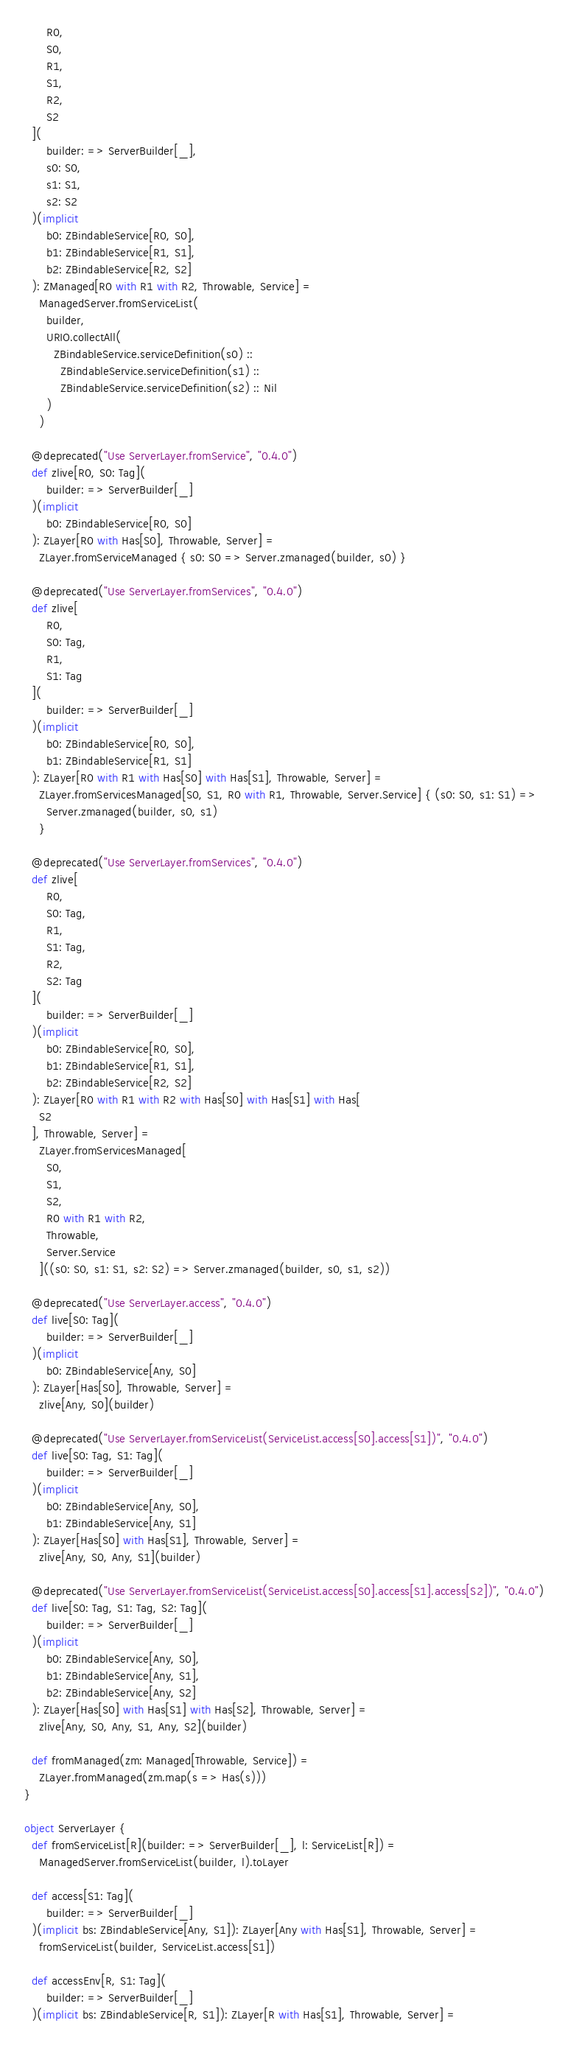Convert code to text. <code><loc_0><loc_0><loc_500><loc_500><_Scala_>      R0,
      S0,
      R1,
      S1,
      R2,
      S2
  ](
      builder: => ServerBuilder[_],
      s0: S0,
      s1: S1,
      s2: S2
  )(implicit
      b0: ZBindableService[R0, S0],
      b1: ZBindableService[R1, S1],
      b2: ZBindableService[R2, S2]
  ): ZManaged[R0 with R1 with R2, Throwable, Service] =
    ManagedServer.fromServiceList(
      builder,
      URIO.collectAll(
        ZBindableService.serviceDefinition(s0) ::
          ZBindableService.serviceDefinition(s1) ::
          ZBindableService.serviceDefinition(s2) :: Nil
      )
    )

  @deprecated("Use ServerLayer.fromService", "0.4.0")
  def zlive[R0, S0: Tag](
      builder: => ServerBuilder[_]
  )(implicit
      b0: ZBindableService[R0, S0]
  ): ZLayer[R0 with Has[S0], Throwable, Server] =
    ZLayer.fromServiceManaged { s0: S0 => Server.zmanaged(builder, s0) }

  @deprecated("Use ServerLayer.fromServices", "0.4.0")
  def zlive[
      R0,
      S0: Tag,
      R1,
      S1: Tag
  ](
      builder: => ServerBuilder[_]
  )(implicit
      b0: ZBindableService[R0, S0],
      b1: ZBindableService[R1, S1]
  ): ZLayer[R0 with R1 with Has[S0] with Has[S1], Throwable, Server] =
    ZLayer.fromServicesManaged[S0, S1, R0 with R1, Throwable, Server.Service] { (s0: S0, s1: S1) =>
      Server.zmanaged(builder, s0, s1)
    }

  @deprecated("Use ServerLayer.fromServices", "0.4.0")
  def zlive[
      R0,
      S0: Tag,
      R1,
      S1: Tag,
      R2,
      S2: Tag
  ](
      builder: => ServerBuilder[_]
  )(implicit
      b0: ZBindableService[R0, S0],
      b1: ZBindableService[R1, S1],
      b2: ZBindableService[R2, S2]
  ): ZLayer[R0 with R1 with R2 with Has[S0] with Has[S1] with Has[
    S2
  ], Throwable, Server] =
    ZLayer.fromServicesManaged[
      S0,
      S1,
      S2,
      R0 with R1 with R2,
      Throwable,
      Server.Service
    ]((s0: S0, s1: S1, s2: S2) => Server.zmanaged(builder, s0, s1, s2))

  @deprecated("Use ServerLayer.access", "0.4.0")
  def live[S0: Tag](
      builder: => ServerBuilder[_]
  )(implicit
      b0: ZBindableService[Any, S0]
  ): ZLayer[Has[S0], Throwable, Server] =
    zlive[Any, S0](builder)

  @deprecated("Use ServerLayer.fromServiceList(ServiceList.access[S0].access[S1])", "0.4.0")
  def live[S0: Tag, S1: Tag](
      builder: => ServerBuilder[_]
  )(implicit
      b0: ZBindableService[Any, S0],
      b1: ZBindableService[Any, S1]
  ): ZLayer[Has[S0] with Has[S1], Throwable, Server] =
    zlive[Any, S0, Any, S1](builder)

  @deprecated("Use ServerLayer.fromServiceList(ServiceList.access[S0].access[S1].access[S2])", "0.4.0")
  def live[S0: Tag, S1: Tag, S2: Tag](
      builder: => ServerBuilder[_]
  )(implicit
      b0: ZBindableService[Any, S0],
      b1: ZBindableService[Any, S1],
      b2: ZBindableService[Any, S2]
  ): ZLayer[Has[S0] with Has[S1] with Has[S2], Throwable, Server] =
    zlive[Any, S0, Any, S1, Any, S2](builder)

  def fromManaged(zm: Managed[Throwable, Service]) =
    ZLayer.fromManaged(zm.map(s => Has(s)))
}

object ServerLayer {
  def fromServiceList[R](builder: => ServerBuilder[_], l: ServiceList[R]) =
    ManagedServer.fromServiceList(builder, l).toLayer

  def access[S1: Tag](
      builder: => ServerBuilder[_]
  )(implicit bs: ZBindableService[Any, S1]): ZLayer[Any with Has[S1], Throwable, Server] =
    fromServiceList(builder, ServiceList.access[S1])

  def accessEnv[R, S1: Tag](
      builder: => ServerBuilder[_]
  )(implicit bs: ZBindableService[R, S1]): ZLayer[R with Has[S1], Throwable, Server] =</code> 